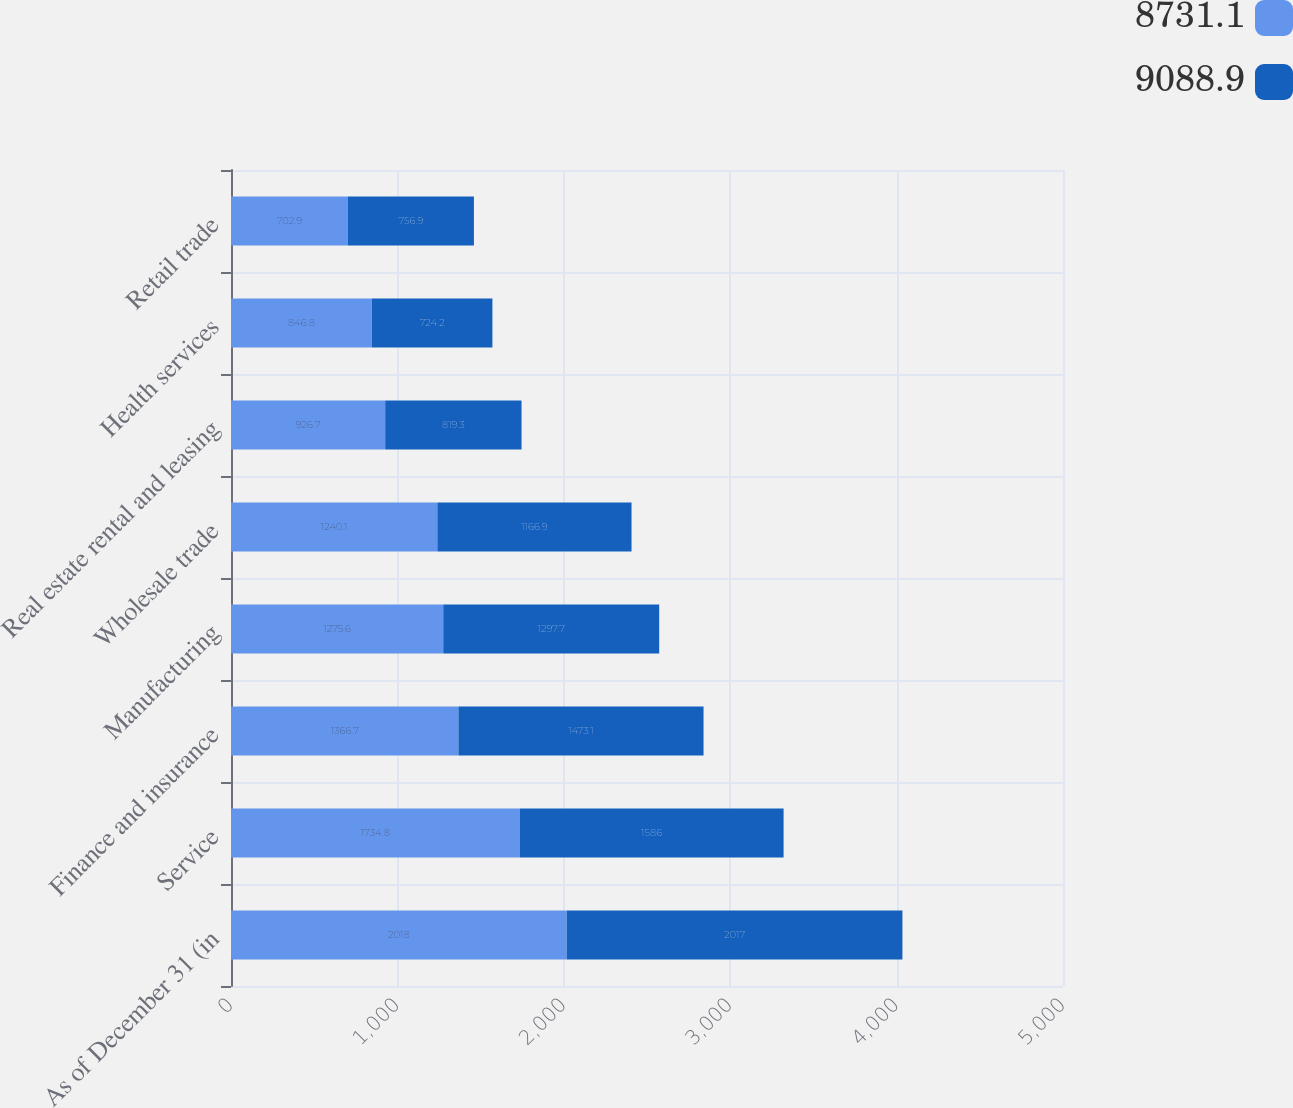<chart> <loc_0><loc_0><loc_500><loc_500><stacked_bar_chart><ecel><fcel>As of December 31 (in<fcel>Service<fcel>Finance and insurance<fcel>Manufacturing<fcel>Wholesale trade<fcel>Real estate rental and leasing<fcel>Health services<fcel>Retail trade<nl><fcel>8731.1<fcel>2018<fcel>1734.8<fcel>1366.7<fcel>1275.6<fcel>1240.1<fcel>926.7<fcel>846.8<fcel>702.9<nl><fcel>9088.9<fcel>2017<fcel>1586<fcel>1473.1<fcel>1297.7<fcel>1166.9<fcel>819.3<fcel>724.2<fcel>756.9<nl></chart> 